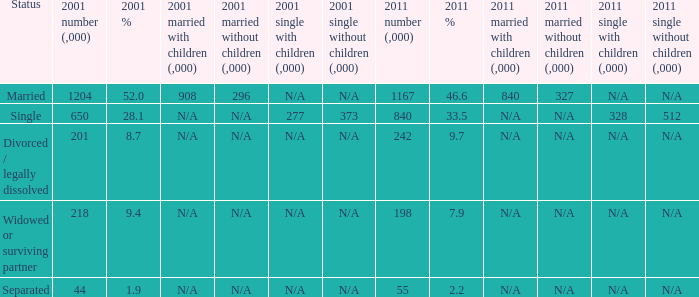How many 2011 % is 7.9? 1.0. Give me the full table as a dictionary. {'header': ['Status', '2001 number (,000)', '2001 %', '2001 married with children (,000)', '2001 married without children (,000)', '2001 single with children (,000)', '2001 single without children (,000)', '2011 number (,000)', '2011 %', '2011 married with children (,000)', '2011 married without children (,000)', '2011 single with children (,000)', '2011 single without children (,000)'], 'rows': [['Married', '1204', '52.0', '908', '296', 'N/A', 'N/A', '1167', '46.6', '840', '327', 'N/A', 'N/A'], ['Single', '650', '28.1', 'N/A', 'N/A', '277', '373', '840', '33.5', 'N/A', 'N/A', '328', '512'], ['Divorced / legally dissolved', '201', '8.7', 'N/A', 'N/A', 'N/A', 'N/A', '242', '9.7', 'N/A', 'N/A', 'N/A', 'N/A'], ['Widowed or surviving partner', '218', '9.4', 'N/A', 'N/A', 'N/A', 'N/A', '198', '7.9', 'N/A', 'N/A', 'N/A', 'N/A'], ['Separated', '44', '1.9', 'N/A', 'N/A', 'N/A', 'N/A', '55', '2.2', 'N/A', 'N/A', 'N/A', 'N/A']]} 